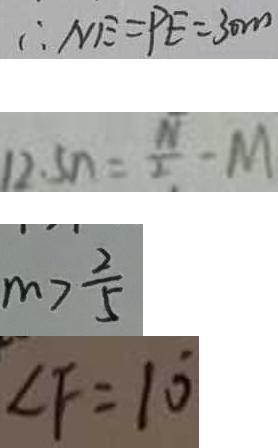<formula> <loc_0><loc_0><loc_500><loc_500>\therefore N E = P E = 3 0 m 
 1 2 . 5 n = \frac { N } { 2 } - M 
 m > \frac { 2 } { 5 } 
 \angle F = 1 0 ^ { \circ }</formula> 